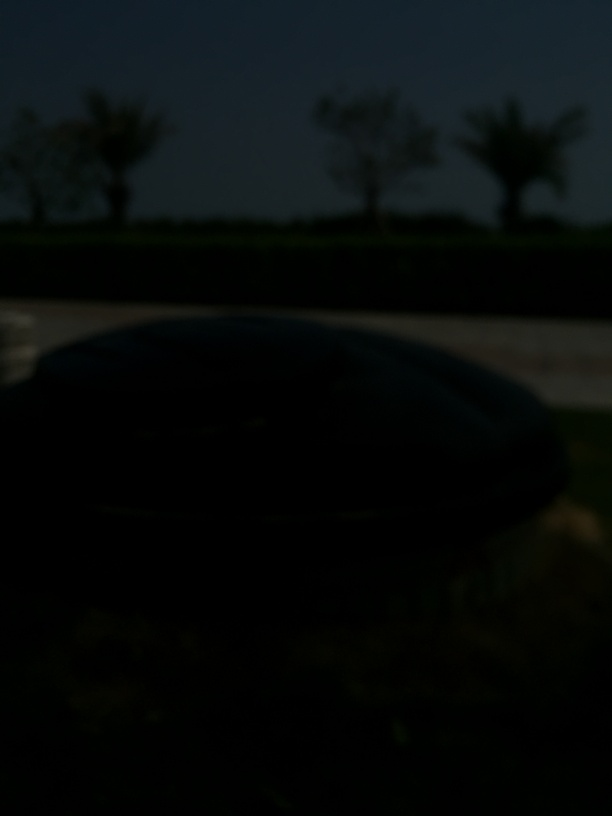Are there any quality issues with this image? Yes, the image is significantly underexposed, resulting in an overall darkness that obscures details. The low light conditions make it difficult to distinguish features and objects within the scene, impeding proper analysis or appreciation of the image. 